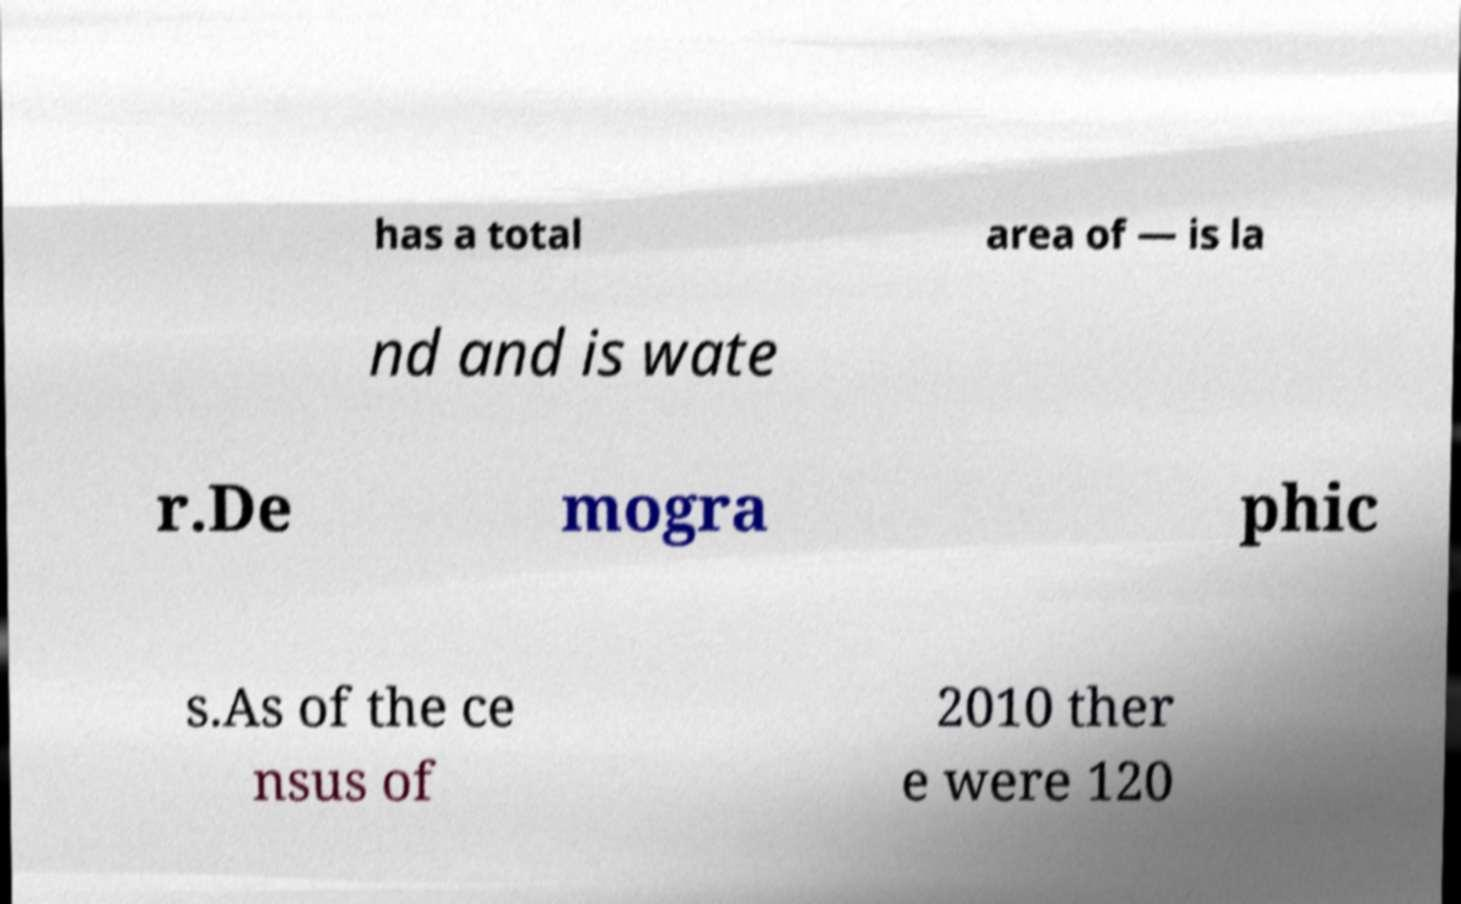Could you assist in decoding the text presented in this image and type it out clearly? has a total area of — is la nd and is wate r.De mogra phic s.As of the ce nsus of 2010 ther e were 120 